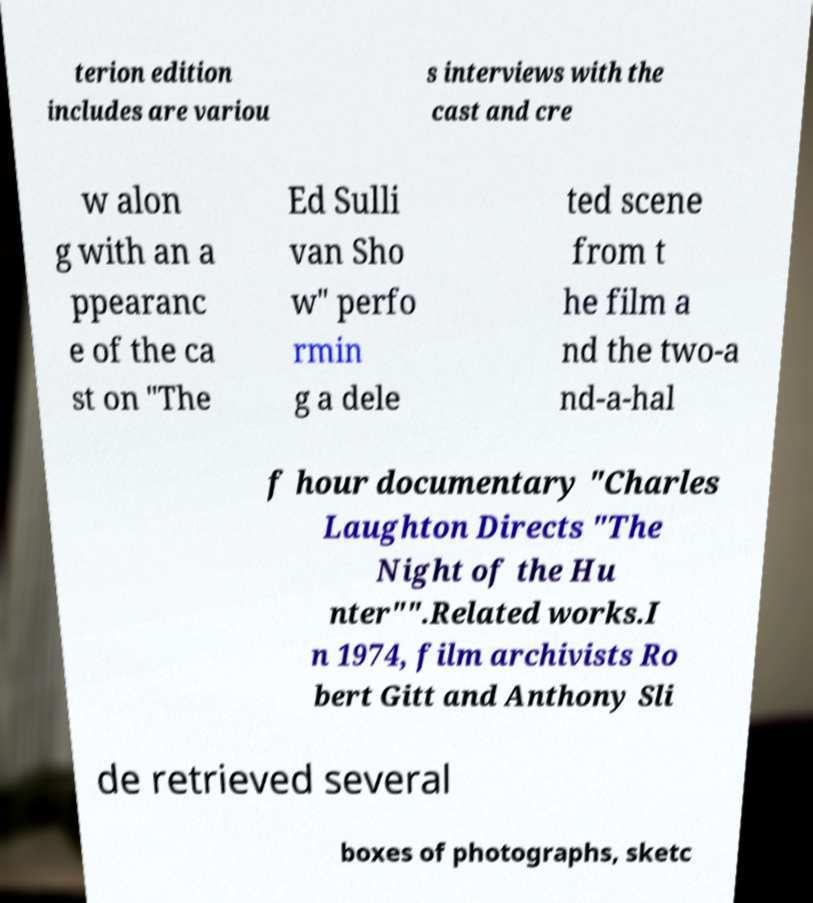Please read and relay the text visible in this image. What does it say? terion edition includes are variou s interviews with the cast and cre w alon g with an a ppearanc e of the ca st on "The Ed Sulli van Sho w" perfo rmin g a dele ted scene from t he film a nd the two-a nd-a-hal f hour documentary "Charles Laughton Directs "The Night of the Hu nter"".Related works.I n 1974, film archivists Ro bert Gitt and Anthony Sli de retrieved several boxes of photographs, sketc 